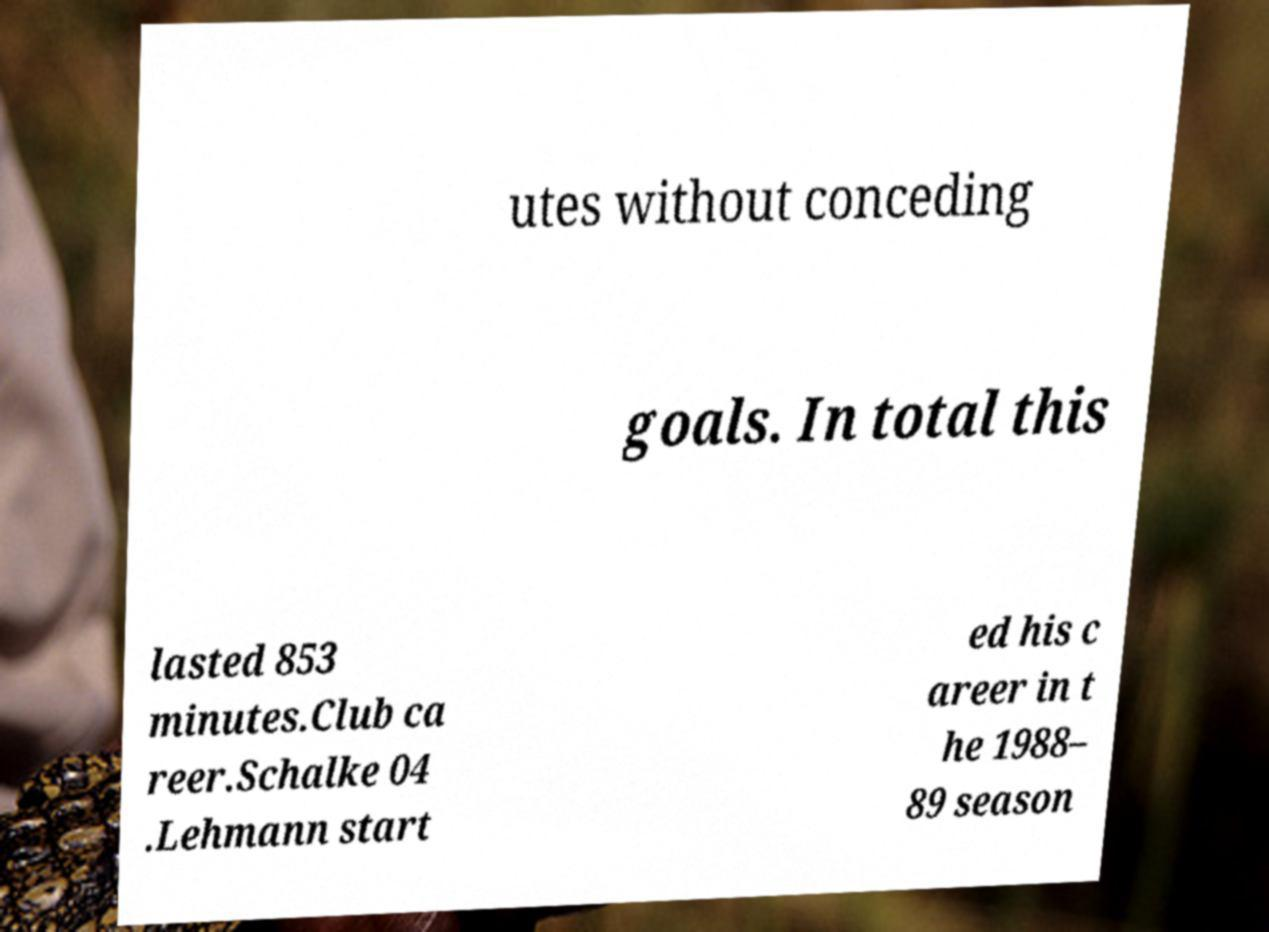What messages or text are displayed in this image? I need them in a readable, typed format. utes without conceding goals. In total this lasted 853 minutes.Club ca reer.Schalke 04 .Lehmann start ed his c areer in t he 1988– 89 season 